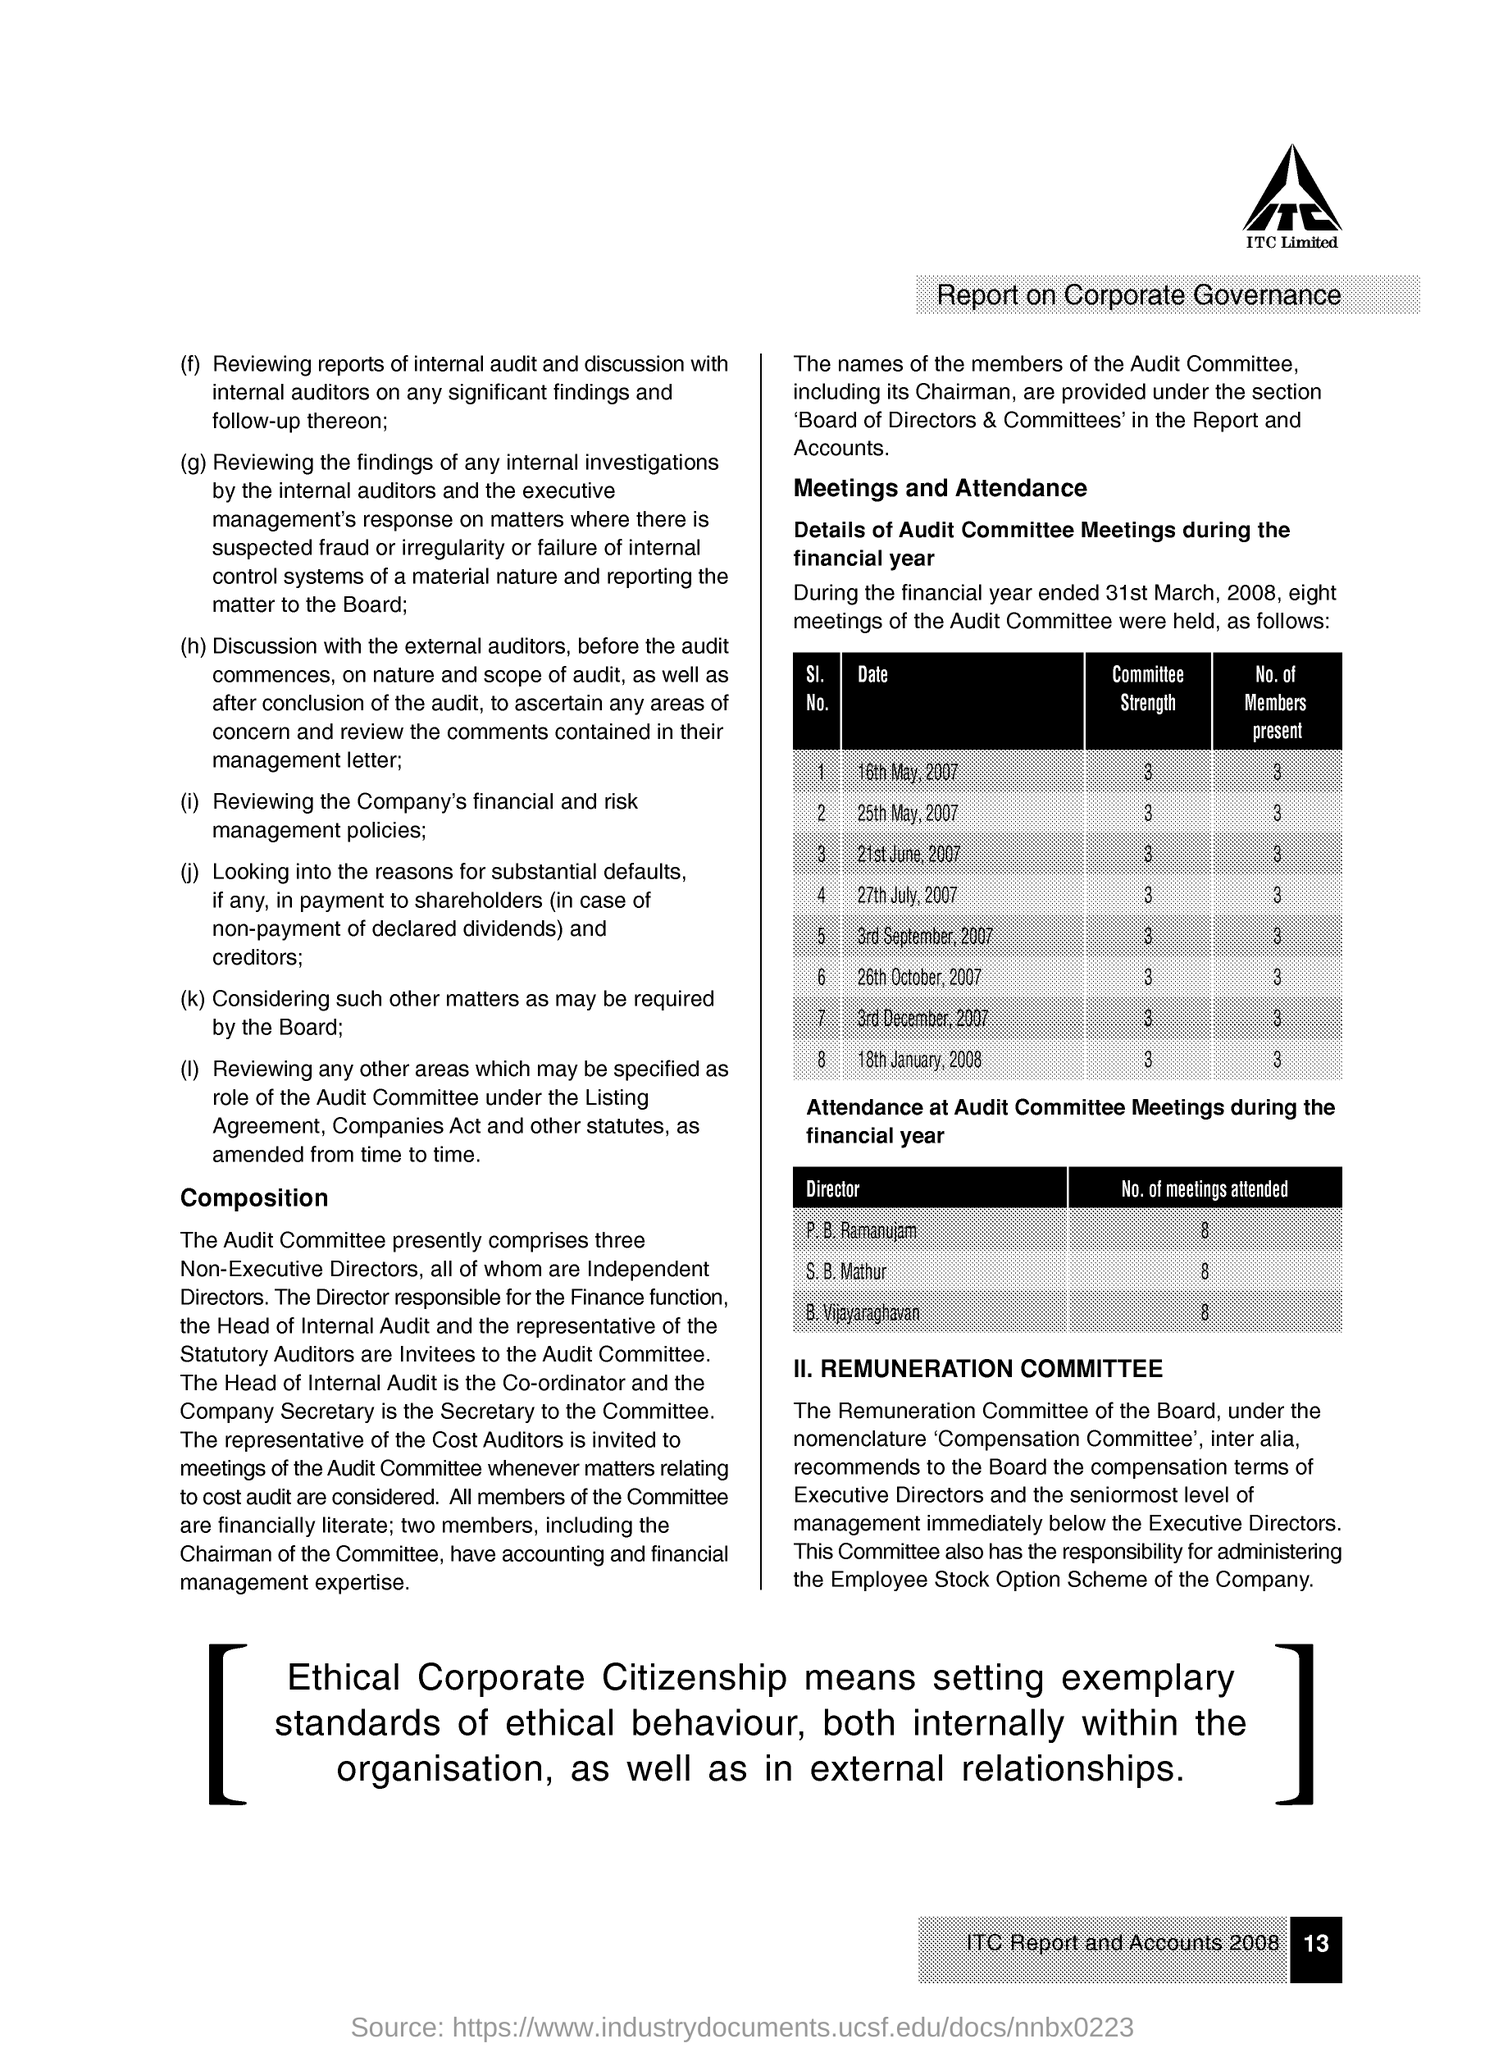Highlight a few significant elements in this photo. S.B. Mathur attended 8 meetings. On September 3rd, 2007, there were 3 members present at the meeting. The committee strength of the meeting held on May 16th, 2007 is 3. This document reports on the topic of corporate governance. 